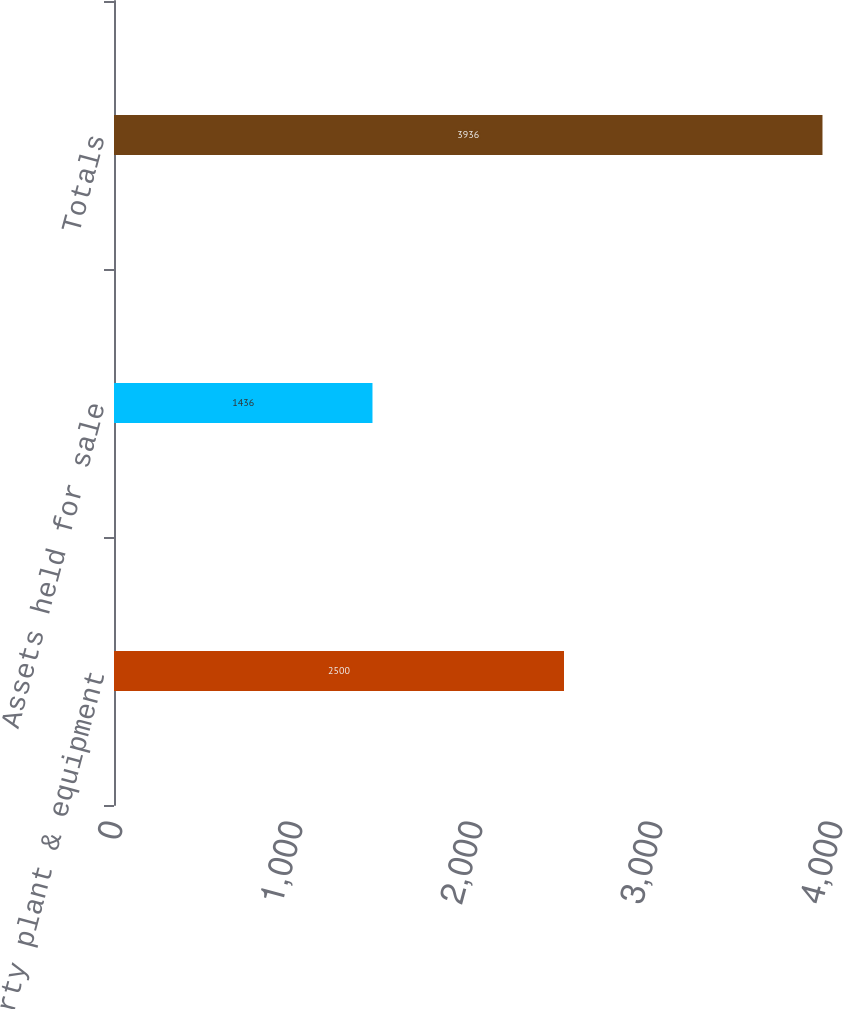Convert chart. <chart><loc_0><loc_0><loc_500><loc_500><bar_chart><fcel>Property plant & equipment<fcel>Assets held for sale<fcel>Totals<nl><fcel>2500<fcel>1436<fcel>3936<nl></chart> 